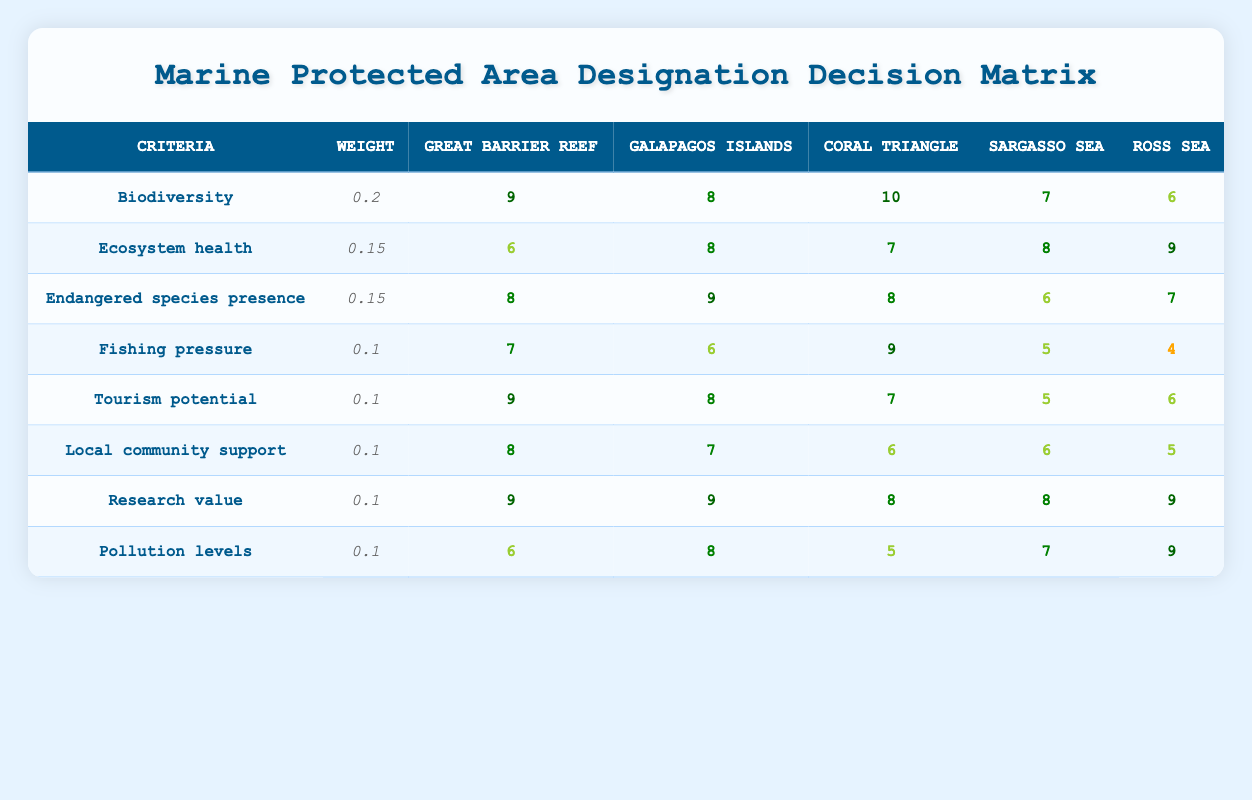What is the score for Biodiversity in the Coral Triangle? The table shows that the score for Biodiversity in the Coral Triangle is 10.
Answer: 10 Which location has the highest score for Ecosystem health? By comparing the scores for Ecosystem health, the Ross Sea has the highest score of 9.
Answer: Ross Sea What is the average score for Local community support across all locations? To find the average score, add the scores: 8 (Great Barrier Reef) + 7 (Galapagos Islands) + 6 (Coral Triangle) + 6 (Sargasso Sea) + 5 (Ross Sea) = 32. There are 5 locations, so the average is 32/5 = 6.4.
Answer: 6.4 Is the Fishing pressure score for the Great Barrier Reef greater than 6? The Fishing pressure score for the Great Barrier Reef is 7, which is greater than 6, so the answer is yes.
Answer: Yes Which criterion has the lowest score in the Sargasso Sea? Looking at the Sargasso Sea row, the criterion with the lowest score is Fishing pressure, which has a score of 5.
Answer: Fishing pressure What is the total score for Research value across all locations? The scores for Research value are 9 (Great Barrier Reef) + 9 (Galapagos Islands) + 8 (Coral Triangle) + 8 (Sargasso Sea) + 9 (Ross Sea) = 43.
Answer: 43 Which location has the highest score for Endangered species presence, and what is that score? The Galapagos Islands has the highest score for Endangered species presence with a score of 9.
Answer: Galapagos Islands, 9 How does the pollution level in the Ross Sea compare to the Coral Triangle? The pollution level in the Ross Sea is 9 and in the Coral Triangle it is 5. Since 9 is greater than 5, pollution levels are higher in the Ross Sea.
Answer: Higher in Ross Sea What is the total weighted score for the Great Barrier Reef? To find the total weighted score, multiply each criterion score by its weight and sum them: (9*0.2) + (6*0.15) + (8*0.15) + (7*0.1) + (9*0.1) + (8*0.1) + (9*0.1) + (6*0.1) = 1.8 + 0.9 + 1.2 + 0.7 + 0.9 + 0.8 + 0.9 + 0.6 = 7.0.
Answer: 7.0 